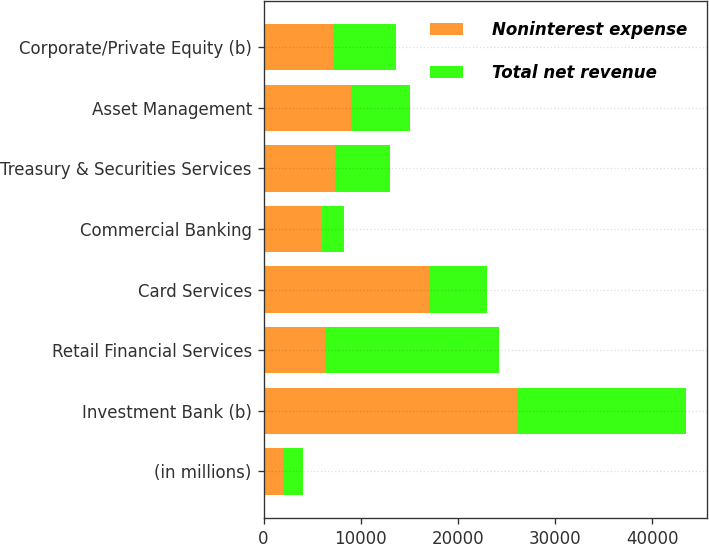<chart> <loc_0><loc_0><loc_500><loc_500><stacked_bar_chart><ecel><fcel>(in millions)<fcel>Investment Bank (b)<fcel>Retail Financial Services<fcel>Card Services<fcel>Commercial Banking<fcel>Treasury & Securities Services<fcel>Asset Management<fcel>Corporate/Private Equity (b)<nl><fcel>Noninterest expense<fcel>2010<fcel>26217<fcel>6355<fcel>17163<fcel>6040<fcel>7381<fcel>8984<fcel>7301<nl><fcel>Total net revenue<fcel>2010<fcel>17265<fcel>17864<fcel>5797<fcel>2199<fcel>5604<fcel>6112<fcel>6355<nl></chart> 